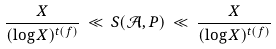<formula> <loc_0><loc_0><loc_500><loc_500>\frac { X } { ( \log X ) ^ { t ( f ) } } \, \ll \, S ( \mathcal { A } , P ) \, \ll \, \frac { X } { ( \log X ) ^ { t ( f ) } }</formula> 